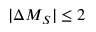Convert formula to latex. <formula><loc_0><loc_0><loc_500><loc_500>| \Delta M _ { S } | \leq 2</formula> 